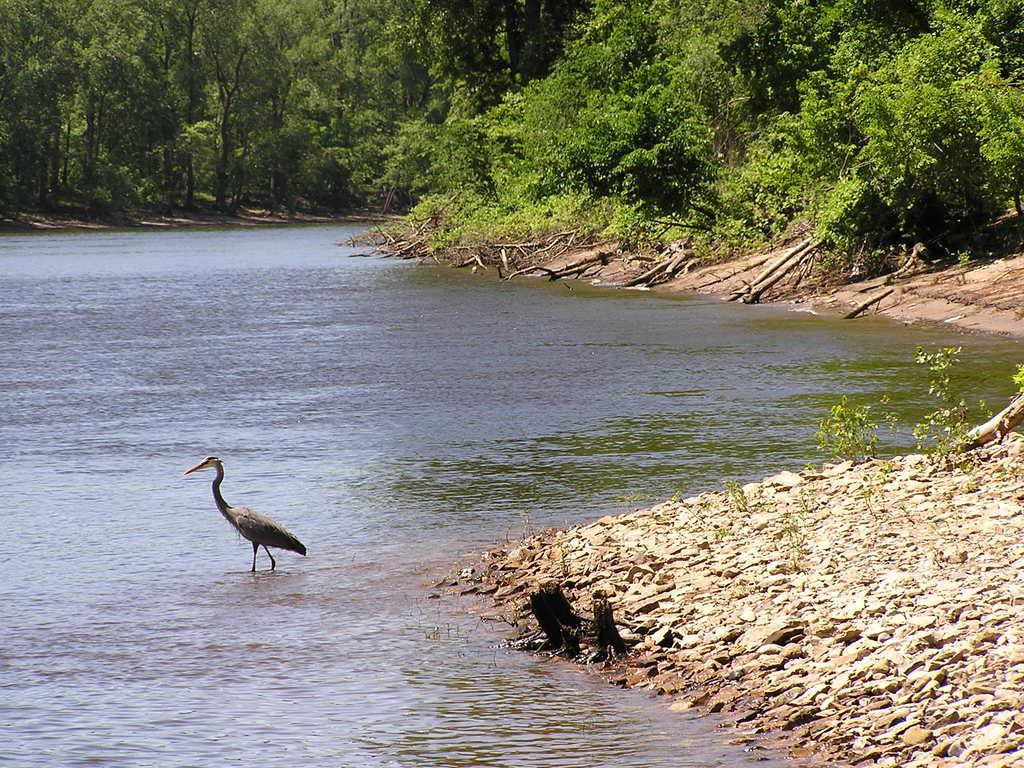What type of animal can be seen in the image? There is a bird in the image. Where is the bird located in the image? The bird is standing in the middle of a pond. What can be seen on either side of the pond? There are trees on either side of the pond. Are the trees on the land or in the water? The trees are on the land. What type of cherries are being played by the band in the image? There is no band or cherries present in the image; it features a bird standing in the middle of a pond with trees on either side. 